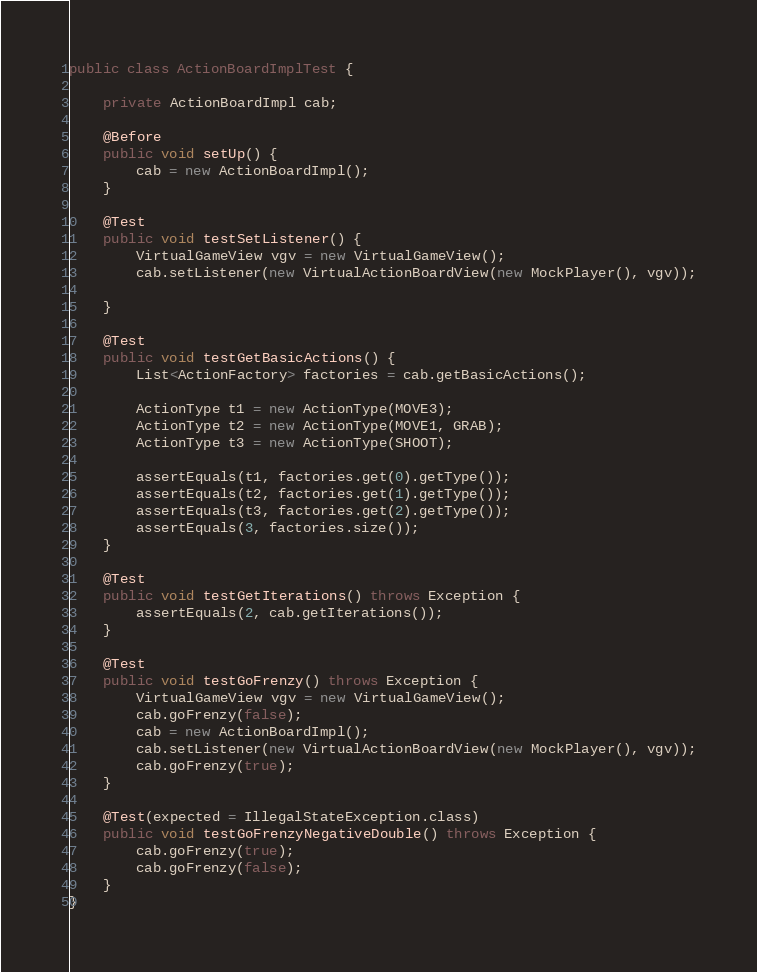<code> <loc_0><loc_0><loc_500><loc_500><_Java_>public class ActionBoardImplTest {

    private ActionBoardImpl cab;

    @Before
    public void setUp() {
        cab = new ActionBoardImpl();
    }

    @Test
    public void testSetListener() {
        VirtualGameView vgv = new VirtualGameView();
        cab.setListener(new VirtualActionBoardView(new MockPlayer(), vgv));

    }

    @Test
    public void testGetBasicActions() {
        List<ActionFactory> factories = cab.getBasicActions();

        ActionType t1 = new ActionType(MOVE3);
        ActionType t2 = new ActionType(MOVE1, GRAB);
        ActionType t3 = new ActionType(SHOOT);

        assertEquals(t1, factories.get(0).getType());
        assertEquals(t2, factories.get(1).getType());
        assertEquals(t3, factories.get(2).getType());
        assertEquals(3, factories.size());
    }

    @Test
    public void testGetIterations() throws Exception {
        assertEquals(2, cab.getIterations());
    }

    @Test
    public void testGoFrenzy() throws Exception {
        VirtualGameView vgv = new VirtualGameView();
        cab.goFrenzy(false);
        cab = new ActionBoardImpl();
        cab.setListener(new VirtualActionBoardView(new MockPlayer(), vgv));
        cab.goFrenzy(true);
    }

    @Test(expected = IllegalStateException.class)
    public void testGoFrenzyNegativeDouble() throws Exception {
        cab.goFrenzy(true);
        cab.goFrenzy(false);
    }
}</code> 